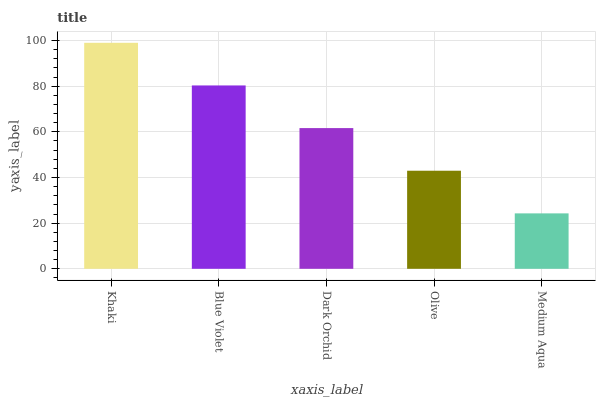Is Medium Aqua the minimum?
Answer yes or no. Yes. Is Khaki the maximum?
Answer yes or no. Yes. Is Blue Violet the minimum?
Answer yes or no. No. Is Blue Violet the maximum?
Answer yes or no. No. Is Khaki greater than Blue Violet?
Answer yes or no. Yes. Is Blue Violet less than Khaki?
Answer yes or no. Yes. Is Blue Violet greater than Khaki?
Answer yes or no. No. Is Khaki less than Blue Violet?
Answer yes or no. No. Is Dark Orchid the high median?
Answer yes or no. Yes. Is Dark Orchid the low median?
Answer yes or no. Yes. Is Blue Violet the high median?
Answer yes or no. No. Is Olive the low median?
Answer yes or no. No. 